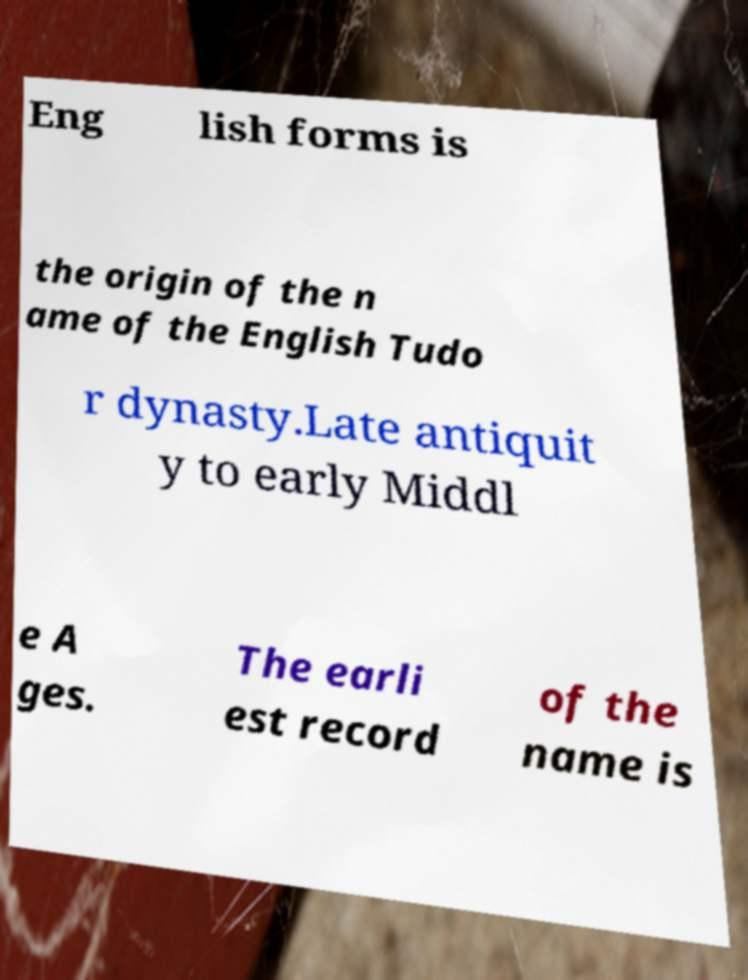For documentation purposes, I need the text within this image transcribed. Could you provide that? Eng lish forms is the origin of the n ame of the English Tudo r dynasty.Late antiquit y to early Middl e A ges. The earli est record of the name is 